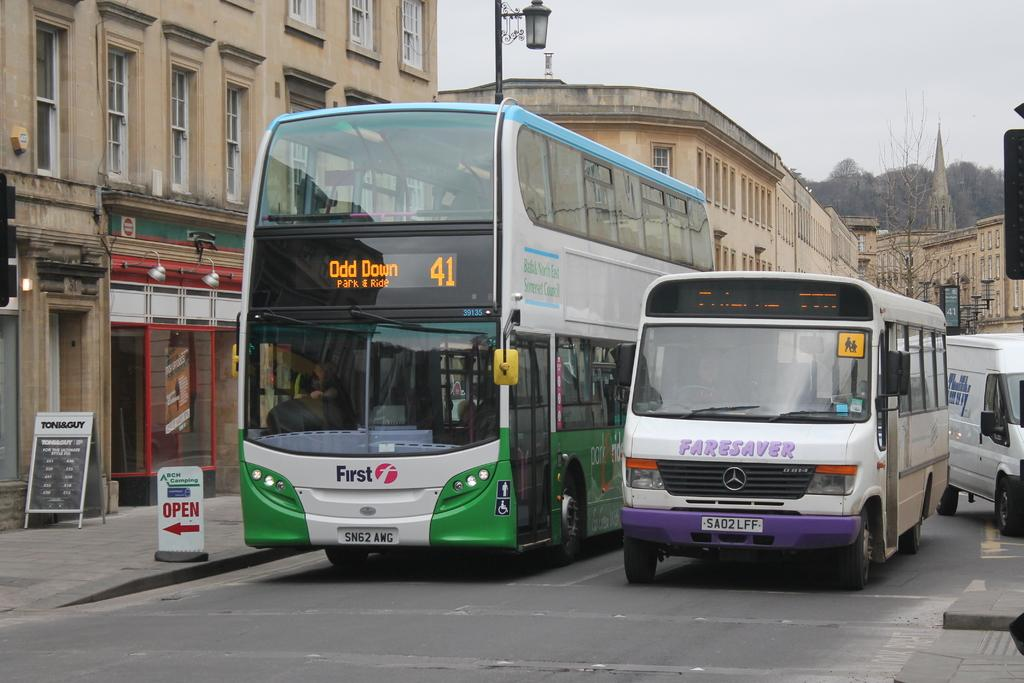What is the main subject in the center of the image? There are vehicles in the center of the image. What can be seen in the background of the image? There are buildings, trees, poles, and posters in the background of the image. What type of collar can be seen on the van in the image? There is no van present in the image, and therefore no collar can be seen on it. 